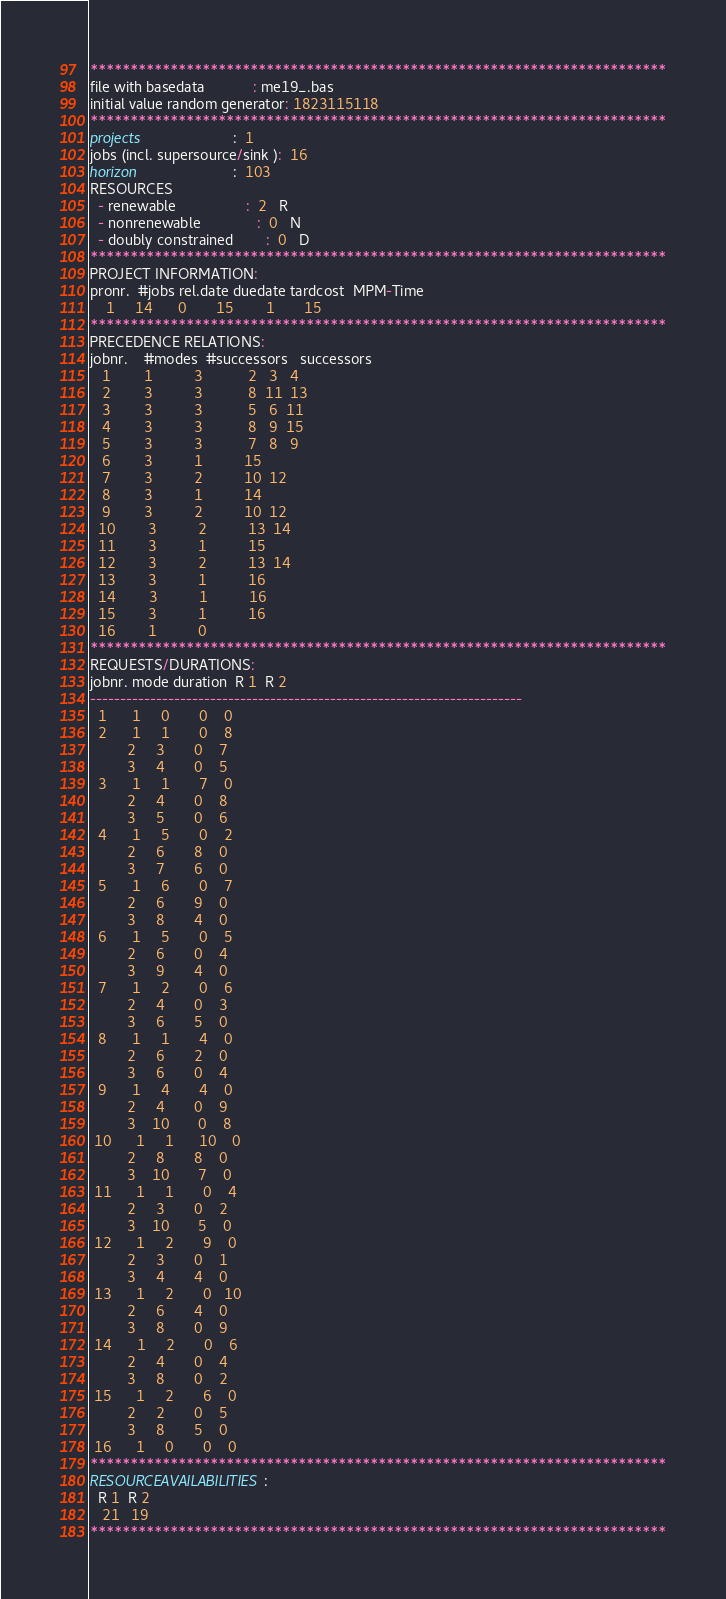<code> <loc_0><loc_0><loc_500><loc_500><_ObjectiveC_>************************************************************************
file with basedata            : me19_.bas
initial value random generator: 1823115118
************************************************************************
projects                      :  1
jobs (incl. supersource/sink ):  16
horizon                       :  103
RESOURCES
  - renewable                 :  2   R
  - nonrenewable              :  0   N
  - doubly constrained        :  0   D
************************************************************************
PROJECT INFORMATION:
pronr.  #jobs rel.date duedate tardcost  MPM-Time
    1     14      0       15        1       15
************************************************************************
PRECEDENCE RELATIONS:
jobnr.    #modes  #successors   successors
   1        1          3           2   3   4
   2        3          3           8  11  13
   3        3          3           5   6  11
   4        3          3           8   9  15
   5        3          3           7   8   9
   6        3          1          15
   7        3          2          10  12
   8        3          1          14
   9        3          2          10  12
  10        3          2          13  14
  11        3          1          15
  12        3          2          13  14
  13        3          1          16
  14        3          1          16
  15        3          1          16
  16        1          0        
************************************************************************
REQUESTS/DURATIONS:
jobnr. mode duration  R 1  R 2
------------------------------------------------------------------------
  1      1     0       0    0
  2      1     1       0    8
         2     3       0    7
         3     4       0    5
  3      1     1       7    0
         2     4       0    8
         3     5       0    6
  4      1     5       0    2
         2     6       8    0
         3     7       6    0
  5      1     6       0    7
         2     6       9    0
         3     8       4    0
  6      1     5       0    5
         2     6       0    4
         3     9       4    0
  7      1     2       0    6
         2     4       0    3
         3     6       5    0
  8      1     1       4    0
         2     6       2    0
         3     6       0    4
  9      1     4       4    0
         2     4       0    9
         3    10       0    8
 10      1     1      10    0
         2     8       8    0
         3    10       7    0
 11      1     1       0    4
         2     3       0    2
         3    10       5    0
 12      1     2       9    0
         2     3       0    1
         3     4       4    0
 13      1     2       0   10
         2     6       4    0
         3     8       0    9
 14      1     2       0    6
         2     4       0    4
         3     8       0    2
 15      1     2       6    0
         2     2       0    5
         3     8       5    0
 16      1     0       0    0
************************************************************************
RESOURCEAVAILABILITIES:
  R 1  R 2
   21   19
************************************************************************
</code> 